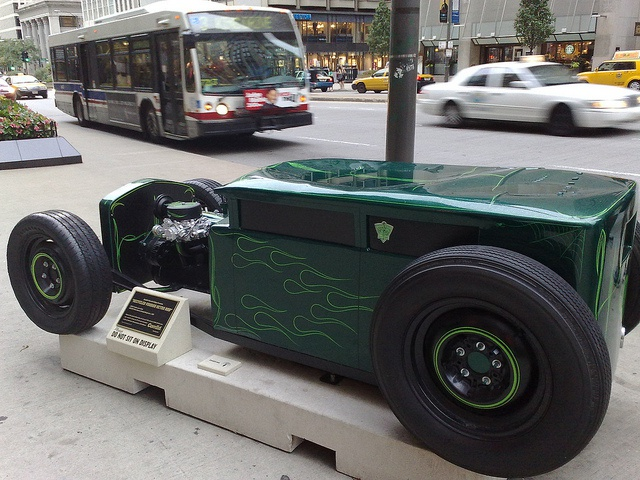Describe the objects in this image and their specific colors. I can see car in ivory, black, gray, darkgray, and teal tones, bus in ivory, black, gray, darkgray, and lightgray tones, car in ivory, white, darkgray, black, and gray tones, potted plant in ivory, black, gray, darkgreen, and darkgray tones, and potted plant in ivory, gray, black, darkgreen, and darkgray tones in this image. 